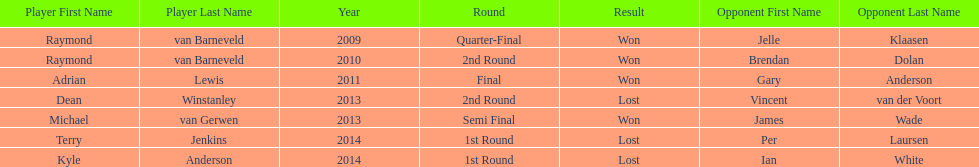Other than kyle anderson, who else lost in 2014? Terry Jenkins. 